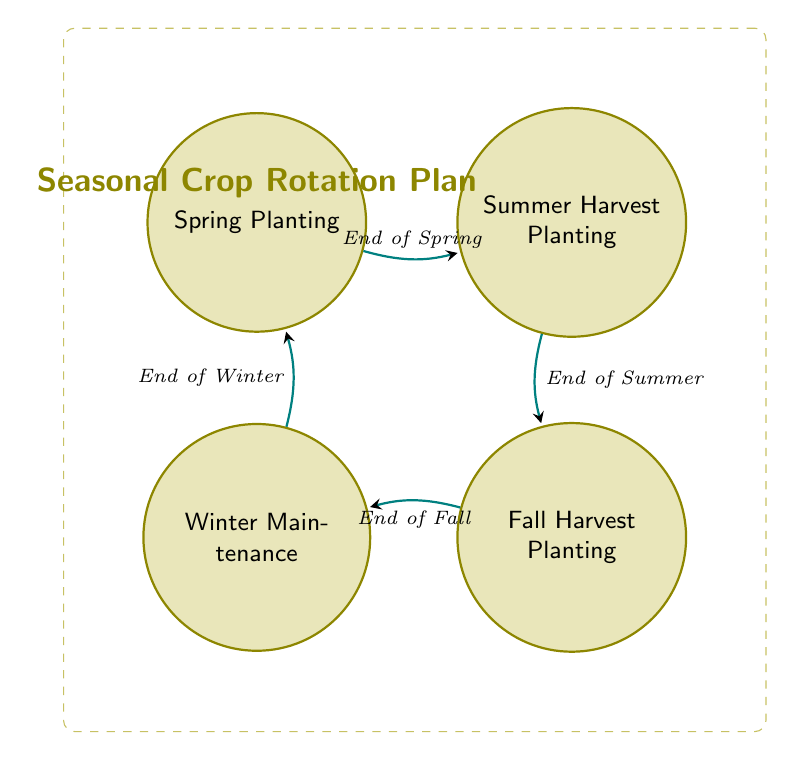What are the actions in Spring Planting? The state "Spring Planting" includes the actions of "Plant radishes," "Plant pea shoots," and "Plant spinach," as shown in the respective state's actions list.
Answer: Plant radishes, Plant pea shoots, Plant spinach How many states are in the diagram? The diagram includes four distinct states: Spring Planting, Summer Harvest Planting, Fall Harvest Planting, and Winter Maintenance. Counting these gives a total of four.
Answer: 4 What is the transition from Summer Harvest Planting to Fall Harvest Planting? The transition between these two states occurs at the "End of Summer," as indicated by the arrow labeled with this condition connecting the two states in the diagram.
Answer: End of Summer What happens at the end of Fall in the diagram? At the end of Fall, the diagram indicates a transition to "Winter Maintenance," which is the action taken at that point in the workflow.
Answer: Transition to Winter Maintenance List all actions in the Winter Maintenance state. The actions listed for the "Winter Maintenance" state are "Compost dead plant material," "Cover crops with mulch," and "Check soil health." These actions are specified under this state's actions in the diagram.
Answer: Compost dead plant material, Cover crops with mulch, Check soil health What state precedes Fall Harvest Planting? The state directly before "Fall Harvest Planting" is "Summer Harvest Planting," as shown in the transition that goes from one to the other at the "End of Summer."
Answer: Summer Harvest Planting How does one return to Spring Planting? Transition back to "Spring Planting" occurs from "Winter Maintenance," specifically when the condition is the "End of Winter," as indicated by the corresponding arrow connecting these two states.
Answer: End of Winter How many actions are performed in Summer Harvest Planting? In the "Summer Harvest Planting" state, there are five actions: "Harvest radishes," "Harvest pea shoots," "Harvest spinach," "Plant heirloom tomatoes," and "Plant eggplants." Counting these actions gives a total of five.
Answer: 5 What is the only action in Fall Harvest Planting that involves planting? The actions in "Fall Harvest Planting" include "Plant garlic" and "Plant kale," where both are planting actions. Since the question asks for planting specifically, either can be the answer, but focusing on "Plant garlic," which is the first mentioned.
Answer: Plant garlic 